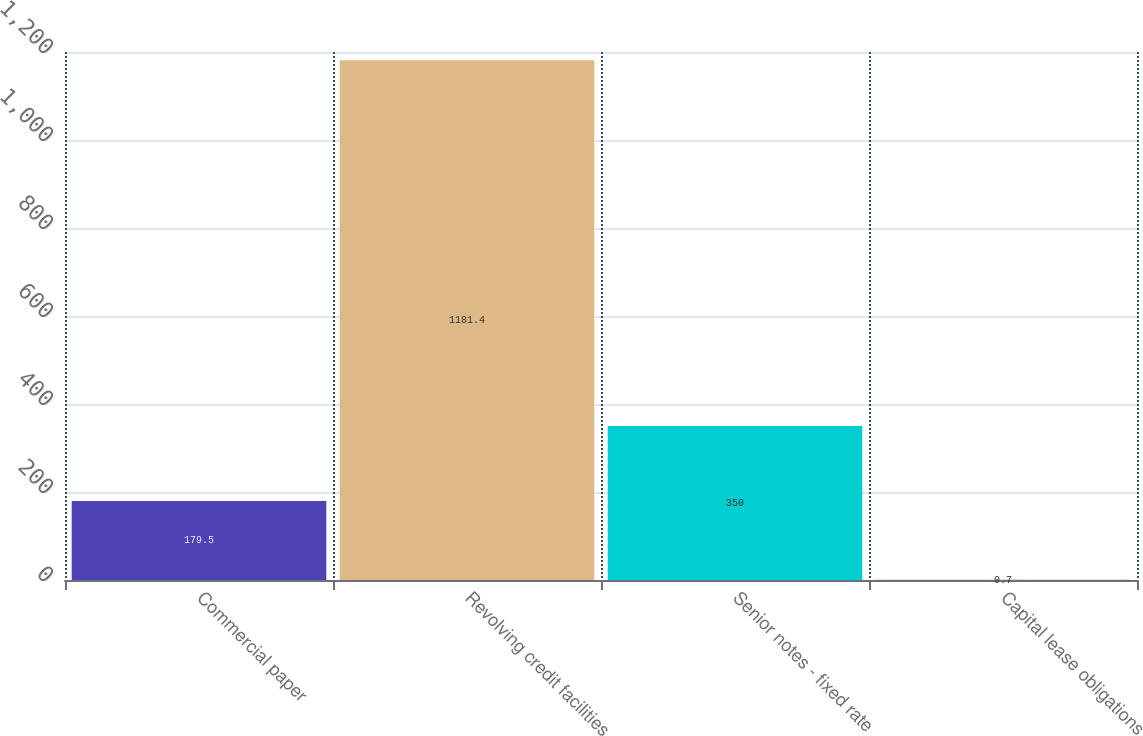Convert chart. <chart><loc_0><loc_0><loc_500><loc_500><bar_chart><fcel>Commercial paper<fcel>Revolving credit facilities<fcel>Senior notes - fixed rate<fcel>Capital lease obligations<nl><fcel>179.5<fcel>1181.4<fcel>350<fcel>0.7<nl></chart> 